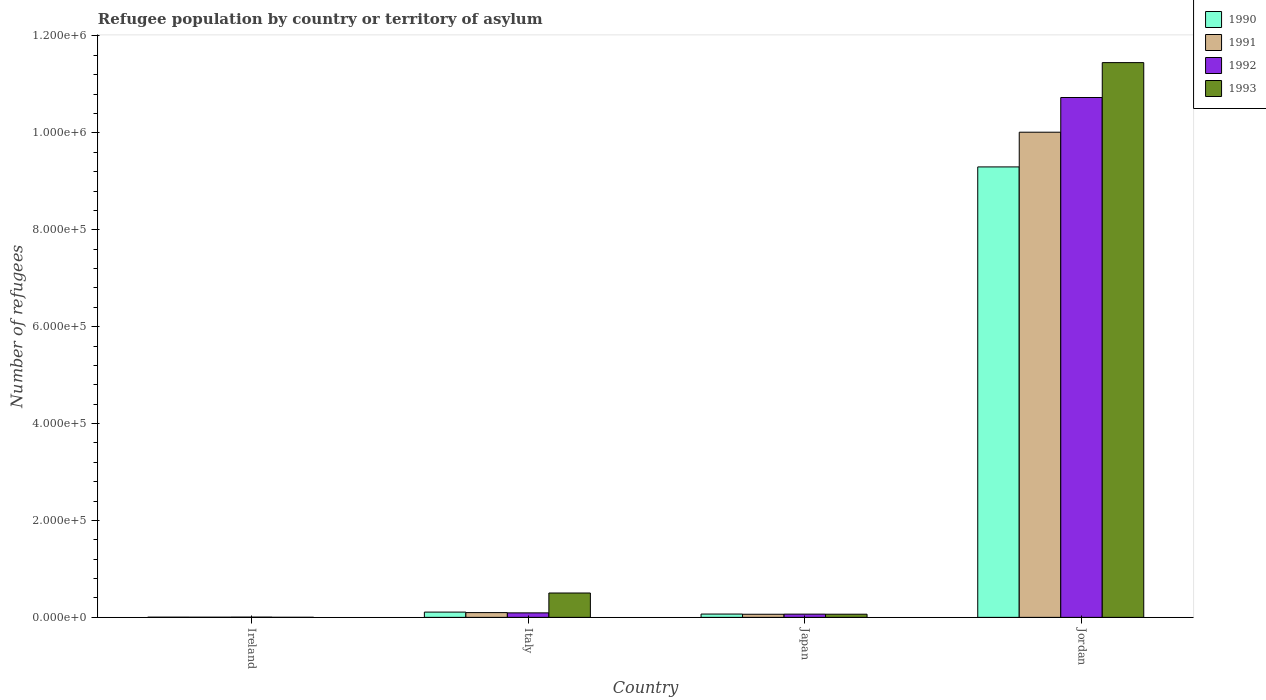How many different coloured bars are there?
Offer a very short reply. 4. Are the number of bars on each tick of the X-axis equal?
Your answer should be compact. Yes. What is the label of the 3rd group of bars from the left?
Offer a terse response. Japan. What is the number of refugees in 1993 in Ireland?
Offer a terse response. 119. Across all countries, what is the maximum number of refugees in 1993?
Your answer should be very brief. 1.15e+06. Across all countries, what is the minimum number of refugees in 1993?
Offer a terse response. 119. In which country was the number of refugees in 1993 maximum?
Your answer should be compact. Jordan. In which country was the number of refugees in 1992 minimum?
Ensure brevity in your answer.  Ireland. What is the total number of refugees in 1993 in the graph?
Offer a terse response. 1.20e+06. What is the difference between the number of refugees in 1992 in Ireland and that in Italy?
Offer a terse response. -8758. What is the difference between the number of refugees in 1990 in Japan and the number of refugees in 1991 in Jordan?
Offer a very short reply. -9.95e+05. What is the average number of refugees in 1993 per country?
Provide a succinct answer. 3.00e+05. What is the difference between the number of refugees of/in 1990 and number of refugees of/in 1991 in Italy?
Ensure brevity in your answer.  1027. What is the ratio of the number of refugees in 1992 in Ireland to that in Jordan?
Your response must be concise. 0. Is the number of refugees in 1992 in Ireland less than that in Jordan?
Provide a short and direct response. Yes. What is the difference between the highest and the second highest number of refugees in 1991?
Offer a very short reply. -3416. What is the difference between the highest and the lowest number of refugees in 1990?
Provide a succinct answer. 9.29e+05. Is the sum of the number of refugees in 1990 in Japan and Jordan greater than the maximum number of refugees in 1991 across all countries?
Your answer should be very brief. No. Is it the case that in every country, the sum of the number of refugees in 1992 and number of refugees in 1990 is greater than the sum of number of refugees in 1993 and number of refugees in 1991?
Provide a succinct answer. No. What does the 3rd bar from the left in Italy represents?
Offer a very short reply. 1992. What is the difference between two consecutive major ticks on the Y-axis?
Make the answer very short. 2.00e+05. Where does the legend appear in the graph?
Your answer should be compact. Top right. How are the legend labels stacked?
Offer a very short reply. Vertical. What is the title of the graph?
Provide a short and direct response. Refugee population by country or territory of asylum. Does "1998" appear as one of the legend labels in the graph?
Give a very brief answer. No. What is the label or title of the Y-axis?
Your answer should be compact. Number of refugees. What is the Number of refugees of 1990 in Ireland?
Make the answer very short. 360. What is the Number of refugees of 1991 in Ireland?
Offer a terse response. 300. What is the Number of refugees in 1993 in Ireland?
Give a very brief answer. 119. What is the Number of refugees in 1990 in Italy?
Offer a terse response. 1.08e+04. What is the Number of refugees of 1991 in Italy?
Give a very brief answer. 9813. What is the Number of refugees in 1992 in Italy?
Your answer should be compact. 9258. What is the Number of refugees of 1993 in Italy?
Make the answer very short. 5.03e+04. What is the Number of refugees in 1990 in Japan?
Your response must be concise. 6819. What is the Number of refugees of 1991 in Japan?
Ensure brevity in your answer.  6397. What is the Number of refugees in 1992 in Japan?
Provide a succinct answer. 6669. What is the Number of refugees in 1993 in Japan?
Offer a terse response. 6495. What is the Number of refugees of 1990 in Jordan?
Ensure brevity in your answer.  9.30e+05. What is the Number of refugees in 1991 in Jordan?
Make the answer very short. 1.00e+06. What is the Number of refugees of 1992 in Jordan?
Your response must be concise. 1.07e+06. What is the Number of refugees of 1993 in Jordan?
Your response must be concise. 1.15e+06. Across all countries, what is the maximum Number of refugees in 1990?
Offer a very short reply. 9.30e+05. Across all countries, what is the maximum Number of refugees of 1991?
Provide a succinct answer. 1.00e+06. Across all countries, what is the maximum Number of refugees in 1992?
Ensure brevity in your answer.  1.07e+06. Across all countries, what is the maximum Number of refugees in 1993?
Keep it short and to the point. 1.15e+06. Across all countries, what is the minimum Number of refugees of 1990?
Provide a succinct answer. 360. Across all countries, what is the minimum Number of refugees in 1991?
Give a very brief answer. 300. Across all countries, what is the minimum Number of refugees in 1992?
Keep it short and to the point. 500. Across all countries, what is the minimum Number of refugees of 1993?
Provide a short and direct response. 119. What is the total Number of refugees in 1990 in the graph?
Keep it short and to the point. 9.48e+05. What is the total Number of refugees of 1991 in the graph?
Give a very brief answer. 1.02e+06. What is the total Number of refugees of 1992 in the graph?
Your response must be concise. 1.09e+06. What is the total Number of refugees of 1993 in the graph?
Your answer should be very brief. 1.20e+06. What is the difference between the Number of refugees of 1990 in Ireland and that in Italy?
Offer a very short reply. -1.05e+04. What is the difference between the Number of refugees of 1991 in Ireland and that in Italy?
Give a very brief answer. -9513. What is the difference between the Number of refugees of 1992 in Ireland and that in Italy?
Offer a very short reply. -8758. What is the difference between the Number of refugees in 1993 in Ireland and that in Italy?
Your response must be concise. -5.02e+04. What is the difference between the Number of refugees of 1990 in Ireland and that in Japan?
Give a very brief answer. -6459. What is the difference between the Number of refugees of 1991 in Ireland and that in Japan?
Your answer should be very brief. -6097. What is the difference between the Number of refugees of 1992 in Ireland and that in Japan?
Offer a very short reply. -6169. What is the difference between the Number of refugees of 1993 in Ireland and that in Japan?
Offer a terse response. -6376. What is the difference between the Number of refugees in 1990 in Ireland and that in Jordan?
Provide a short and direct response. -9.29e+05. What is the difference between the Number of refugees of 1991 in Ireland and that in Jordan?
Offer a terse response. -1.00e+06. What is the difference between the Number of refugees of 1992 in Ireland and that in Jordan?
Provide a succinct answer. -1.07e+06. What is the difference between the Number of refugees in 1993 in Ireland and that in Jordan?
Make the answer very short. -1.14e+06. What is the difference between the Number of refugees in 1990 in Italy and that in Japan?
Make the answer very short. 4021. What is the difference between the Number of refugees in 1991 in Italy and that in Japan?
Provide a short and direct response. 3416. What is the difference between the Number of refugees of 1992 in Italy and that in Japan?
Keep it short and to the point. 2589. What is the difference between the Number of refugees of 1993 in Italy and that in Japan?
Keep it short and to the point. 4.38e+04. What is the difference between the Number of refugees in 1990 in Italy and that in Jordan?
Make the answer very short. -9.19e+05. What is the difference between the Number of refugees of 1991 in Italy and that in Jordan?
Offer a terse response. -9.92e+05. What is the difference between the Number of refugees of 1992 in Italy and that in Jordan?
Give a very brief answer. -1.06e+06. What is the difference between the Number of refugees in 1993 in Italy and that in Jordan?
Keep it short and to the point. -1.09e+06. What is the difference between the Number of refugees of 1990 in Japan and that in Jordan?
Your response must be concise. -9.23e+05. What is the difference between the Number of refugees of 1991 in Japan and that in Jordan?
Your response must be concise. -9.95e+05. What is the difference between the Number of refugees in 1992 in Japan and that in Jordan?
Keep it short and to the point. -1.07e+06. What is the difference between the Number of refugees of 1993 in Japan and that in Jordan?
Your answer should be compact. -1.14e+06. What is the difference between the Number of refugees in 1990 in Ireland and the Number of refugees in 1991 in Italy?
Your answer should be compact. -9453. What is the difference between the Number of refugees in 1990 in Ireland and the Number of refugees in 1992 in Italy?
Give a very brief answer. -8898. What is the difference between the Number of refugees of 1990 in Ireland and the Number of refugees of 1993 in Italy?
Provide a short and direct response. -4.99e+04. What is the difference between the Number of refugees in 1991 in Ireland and the Number of refugees in 1992 in Italy?
Offer a very short reply. -8958. What is the difference between the Number of refugees of 1991 in Ireland and the Number of refugees of 1993 in Italy?
Your answer should be very brief. -5.00e+04. What is the difference between the Number of refugees of 1992 in Ireland and the Number of refugees of 1993 in Italy?
Make the answer very short. -4.98e+04. What is the difference between the Number of refugees in 1990 in Ireland and the Number of refugees in 1991 in Japan?
Your response must be concise. -6037. What is the difference between the Number of refugees in 1990 in Ireland and the Number of refugees in 1992 in Japan?
Offer a terse response. -6309. What is the difference between the Number of refugees in 1990 in Ireland and the Number of refugees in 1993 in Japan?
Offer a terse response. -6135. What is the difference between the Number of refugees of 1991 in Ireland and the Number of refugees of 1992 in Japan?
Make the answer very short. -6369. What is the difference between the Number of refugees of 1991 in Ireland and the Number of refugees of 1993 in Japan?
Offer a terse response. -6195. What is the difference between the Number of refugees in 1992 in Ireland and the Number of refugees in 1993 in Japan?
Your answer should be compact. -5995. What is the difference between the Number of refugees of 1990 in Ireland and the Number of refugees of 1991 in Jordan?
Ensure brevity in your answer.  -1.00e+06. What is the difference between the Number of refugees in 1990 in Ireland and the Number of refugees in 1992 in Jordan?
Your response must be concise. -1.07e+06. What is the difference between the Number of refugees in 1990 in Ireland and the Number of refugees in 1993 in Jordan?
Your answer should be very brief. -1.14e+06. What is the difference between the Number of refugees in 1991 in Ireland and the Number of refugees in 1992 in Jordan?
Offer a very short reply. -1.07e+06. What is the difference between the Number of refugees in 1991 in Ireland and the Number of refugees in 1993 in Jordan?
Make the answer very short. -1.14e+06. What is the difference between the Number of refugees of 1992 in Ireland and the Number of refugees of 1993 in Jordan?
Your answer should be compact. -1.14e+06. What is the difference between the Number of refugees in 1990 in Italy and the Number of refugees in 1991 in Japan?
Give a very brief answer. 4443. What is the difference between the Number of refugees in 1990 in Italy and the Number of refugees in 1992 in Japan?
Provide a short and direct response. 4171. What is the difference between the Number of refugees in 1990 in Italy and the Number of refugees in 1993 in Japan?
Offer a very short reply. 4345. What is the difference between the Number of refugees of 1991 in Italy and the Number of refugees of 1992 in Japan?
Offer a terse response. 3144. What is the difference between the Number of refugees in 1991 in Italy and the Number of refugees in 1993 in Japan?
Make the answer very short. 3318. What is the difference between the Number of refugees in 1992 in Italy and the Number of refugees in 1993 in Japan?
Your response must be concise. 2763. What is the difference between the Number of refugees of 1990 in Italy and the Number of refugees of 1991 in Jordan?
Offer a very short reply. -9.91e+05. What is the difference between the Number of refugees in 1990 in Italy and the Number of refugees in 1992 in Jordan?
Offer a very short reply. -1.06e+06. What is the difference between the Number of refugees of 1990 in Italy and the Number of refugees of 1993 in Jordan?
Give a very brief answer. -1.13e+06. What is the difference between the Number of refugees in 1991 in Italy and the Number of refugees in 1992 in Jordan?
Offer a very short reply. -1.06e+06. What is the difference between the Number of refugees in 1991 in Italy and the Number of refugees in 1993 in Jordan?
Your answer should be compact. -1.14e+06. What is the difference between the Number of refugees in 1992 in Italy and the Number of refugees in 1993 in Jordan?
Your answer should be very brief. -1.14e+06. What is the difference between the Number of refugees of 1990 in Japan and the Number of refugees of 1991 in Jordan?
Give a very brief answer. -9.95e+05. What is the difference between the Number of refugees in 1990 in Japan and the Number of refugees in 1992 in Jordan?
Ensure brevity in your answer.  -1.07e+06. What is the difference between the Number of refugees in 1990 in Japan and the Number of refugees in 1993 in Jordan?
Your response must be concise. -1.14e+06. What is the difference between the Number of refugees of 1991 in Japan and the Number of refugees of 1992 in Jordan?
Ensure brevity in your answer.  -1.07e+06. What is the difference between the Number of refugees in 1991 in Japan and the Number of refugees in 1993 in Jordan?
Your answer should be compact. -1.14e+06. What is the difference between the Number of refugees of 1992 in Japan and the Number of refugees of 1993 in Jordan?
Offer a very short reply. -1.14e+06. What is the average Number of refugees in 1990 per country?
Offer a terse response. 2.37e+05. What is the average Number of refugees in 1991 per country?
Offer a terse response. 2.54e+05. What is the average Number of refugees in 1992 per country?
Your answer should be compact. 2.72e+05. What is the average Number of refugees in 1993 per country?
Ensure brevity in your answer.  3.00e+05. What is the difference between the Number of refugees of 1990 and Number of refugees of 1992 in Ireland?
Your answer should be compact. -140. What is the difference between the Number of refugees of 1990 and Number of refugees of 1993 in Ireland?
Your answer should be very brief. 241. What is the difference between the Number of refugees of 1991 and Number of refugees of 1992 in Ireland?
Provide a short and direct response. -200. What is the difference between the Number of refugees of 1991 and Number of refugees of 1993 in Ireland?
Offer a very short reply. 181. What is the difference between the Number of refugees in 1992 and Number of refugees in 1993 in Ireland?
Offer a terse response. 381. What is the difference between the Number of refugees in 1990 and Number of refugees in 1991 in Italy?
Keep it short and to the point. 1027. What is the difference between the Number of refugees in 1990 and Number of refugees in 1992 in Italy?
Offer a terse response. 1582. What is the difference between the Number of refugees in 1990 and Number of refugees in 1993 in Italy?
Offer a very short reply. -3.94e+04. What is the difference between the Number of refugees in 1991 and Number of refugees in 1992 in Italy?
Provide a succinct answer. 555. What is the difference between the Number of refugees of 1991 and Number of refugees of 1993 in Italy?
Provide a succinct answer. -4.05e+04. What is the difference between the Number of refugees in 1992 and Number of refugees in 1993 in Italy?
Offer a terse response. -4.10e+04. What is the difference between the Number of refugees in 1990 and Number of refugees in 1991 in Japan?
Make the answer very short. 422. What is the difference between the Number of refugees in 1990 and Number of refugees in 1992 in Japan?
Your answer should be very brief. 150. What is the difference between the Number of refugees in 1990 and Number of refugees in 1993 in Japan?
Provide a short and direct response. 324. What is the difference between the Number of refugees of 1991 and Number of refugees of 1992 in Japan?
Give a very brief answer. -272. What is the difference between the Number of refugees in 1991 and Number of refugees in 1993 in Japan?
Make the answer very short. -98. What is the difference between the Number of refugees of 1992 and Number of refugees of 1993 in Japan?
Make the answer very short. 174. What is the difference between the Number of refugees of 1990 and Number of refugees of 1991 in Jordan?
Provide a succinct answer. -7.16e+04. What is the difference between the Number of refugees of 1990 and Number of refugees of 1992 in Jordan?
Offer a very short reply. -1.43e+05. What is the difference between the Number of refugees in 1990 and Number of refugees in 1993 in Jordan?
Ensure brevity in your answer.  -2.15e+05. What is the difference between the Number of refugees in 1991 and Number of refugees in 1992 in Jordan?
Provide a succinct answer. -7.16e+04. What is the difference between the Number of refugees of 1991 and Number of refugees of 1993 in Jordan?
Keep it short and to the point. -1.44e+05. What is the difference between the Number of refugees of 1992 and Number of refugees of 1993 in Jordan?
Your response must be concise. -7.20e+04. What is the ratio of the Number of refugees of 1990 in Ireland to that in Italy?
Provide a short and direct response. 0.03. What is the ratio of the Number of refugees in 1991 in Ireland to that in Italy?
Provide a short and direct response. 0.03. What is the ratio of the Number of refugees of 1992 in Ireland to that in Italy?
Offer a very short reply. 0.05. What is the ratio of the Number of refugees in 1993 in Ireland to that in Italy?
Provide a succinct answer. 0. What is the ratio of the Number of refugees of 1990 in Ireland to that in Japan?
Your answer should be compact. 0.05. What is the ratio of the Number of refugees of 1991 in Ireland to that in Japan?
Offer a very short reply. 0.05. What is the ratio of the Number of refugees of 1992 in Ireland to that in Japan?
Your response must be concise. 0.07. What is the ratio of the Number of refugees in 1993 in Ireland to that in Japan?
Offer a very short reply. 0.02. What is the ratio of the Number of refugees of 1990 in Ireland to that in Jordan?
Provide a succinct answer. 0. What is the ratio of the Number of refugees of 1993 in Ireland to that in Jordan?
Provide a succinct answer. 0. What is the ratio of the Number of refugees in 1990 in Italy to that in Japan?
Make the answer very short. 1.59. What is the ratio of the Number of refugees of 1991 in Italy to that in Japan?
Your answer should be compact. 1.53. What is the ratio of the Number of refugees of 1992 in Italy to that in Japan?
Give a very brief answer. 1.39. What is the ratio of the Number of refugees of 1993 in Italy to that in Japan?
Provide a succinct answer. 7.74. What is the ratio of the Number of refugees of 1990 in Italy to that in Jordan?
Your answer should be compact. 0.01. What is the ratio of the Number of refugees of 1991 in Italy to that in Jordan?
Provide a short and direct response. 0.01. What is the ratio of the Number of refugees in 1992 in Italy to that in Jordan?
Your answer should be compact. 0.01. What is the ratio of the Number of refugees in 1993 in Italy to that in Jordan?
Offer a terse response. 0.04. What is the ratio of the Number of refugees of 1990 in Japan to that in Jordan?
Give a very brief answer. 0.01. What is the ratio of the Number of refugees of 1991 in Japan to that in Jordan?
Provide a succinct answer. 0.01. What is the ratio of the Number of refugees of 1992 in Japan to that in Jordan?
Ensure brevity in your answer.  0.01. What is the ratio of the Number of refugees of 1993 in Japan to that in Jordan?
Your response must be concise. 0.01. What is the difference between the highest and the second highest Number of refugees of 1990?
Offer a terse response. 9.19e+05. What is the difference between the highest and the second highest Number of refugees of 1991?
Ensure brevity in your answer.  9.92e+05. What is the difference between the highest and the second highest Number of refugees in 1992?
Offer a very short reply. 1.06e+06. What is the difference between the highest and the second highest Number of refugees of 1993?
Your answer should be very brief. 1.09e+06. What is the difference between the highest and the lowest Number of refugees of 1990?
Your answer should be very brief. 9.29e+05. What is the difference between the highest and the lowest Number of refugees of 1991?
Offer a terse response. 1.00e+06. What is the difference between the highest and the lowest Number of refugees in 1992?
Provide a succinct answer. 1.07e+06. What is the difference between the highest and the lowest Number of refugees in 1993?
Offer a terse response. 1.14e+06. 